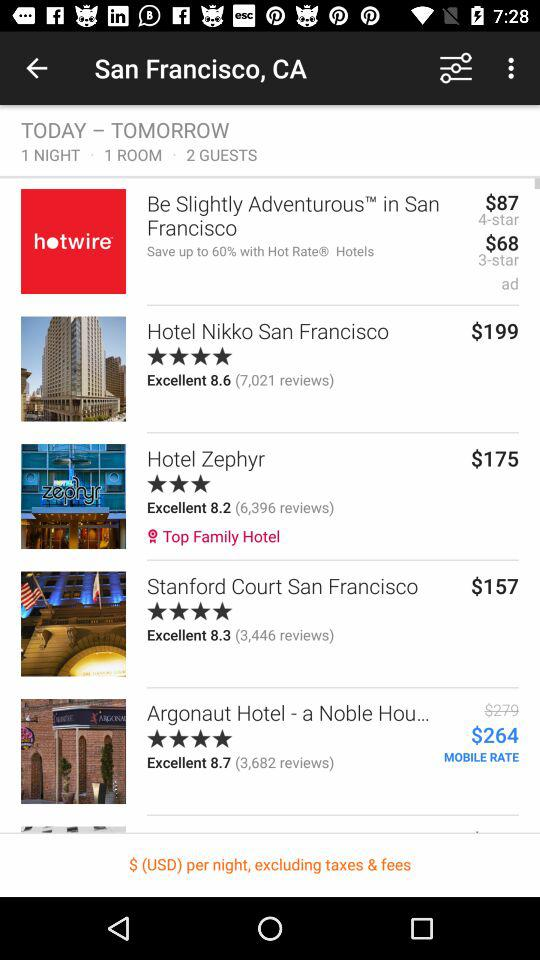What is the number of reviews for "Hotel Nikko"? The number of reviews for "Hotel Nikko" is 7,021. 